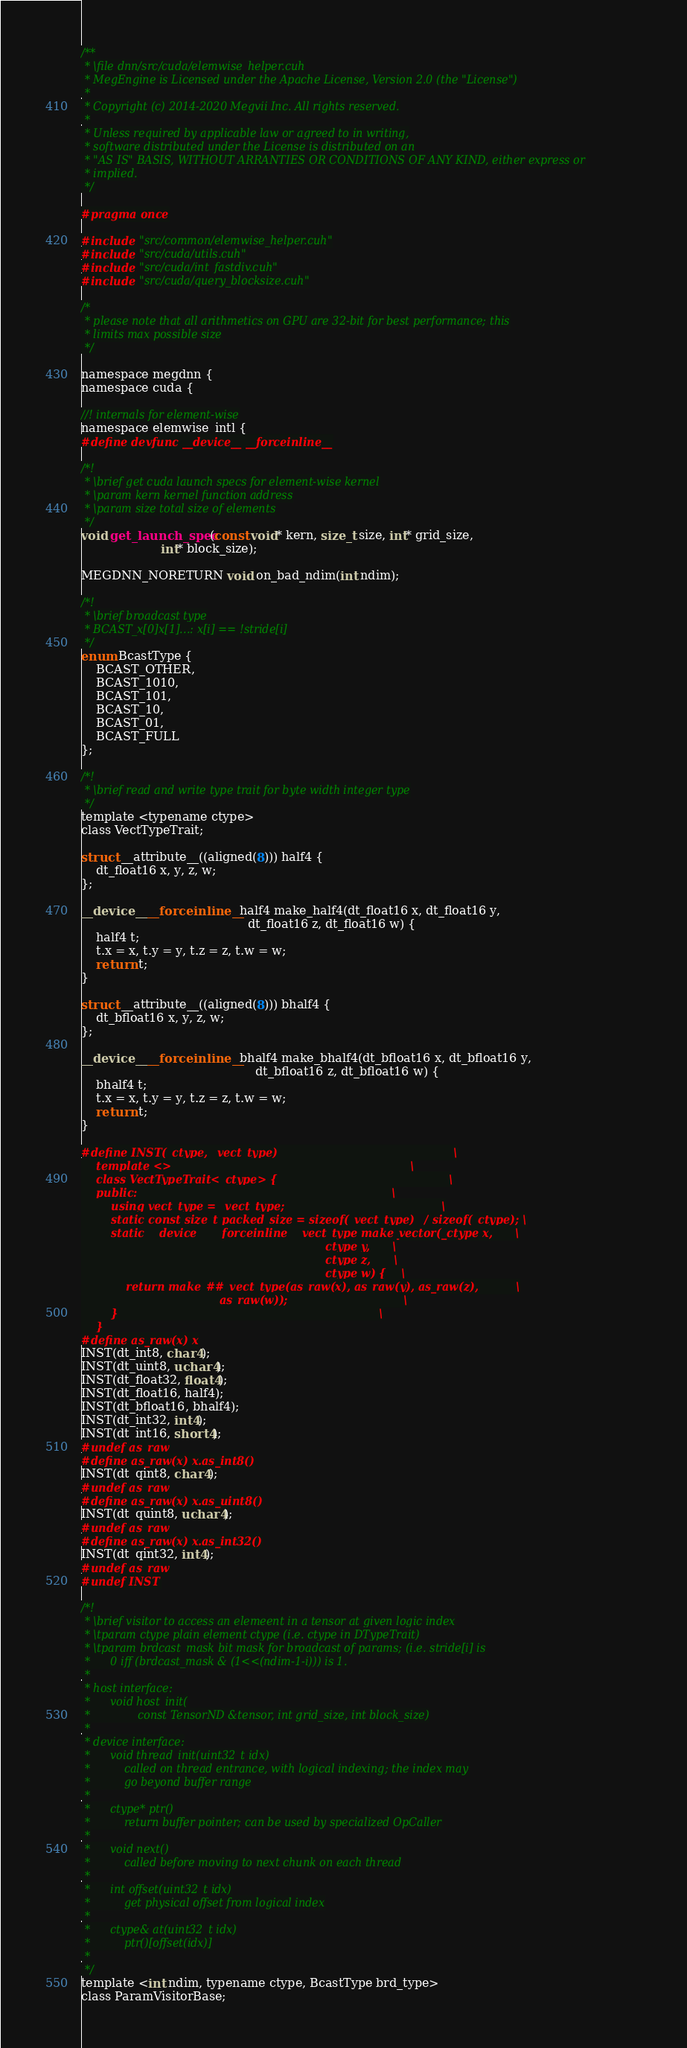<code> <loc_0><loc_0><loc_500><loc_500><_Cuda_>/**
 * \file dnn/src/cuda/elemwise_helper.cuh
 * MegEngine is Licensed under the Apache License, Version 2.0 (the "License")
 *
 * Copyright (c) 2014-2020 Megvii Inc. All rights reserved.
 *
 * Unless required by applicable law or agreed to in writing,
 * software distributed under the License is distributed on an
 * "AS IS" BASIS, WITHOUT ARRANTIES OR CONDITIONS OF ANY KIND, either express or
 * implied.
 */

#pragma once

#include "src/common/elemwise_helper.cuh"
#include "src/cuda/utils.cuh"
#include "src/cuda/int_fastdiv.cuh"
#include "src/cuda/query_blocksize.cuh"

/*
 * please note that all arithmetics on GPU are 32-bit for best performance; this
 * limits max possible size
 */

namespace megdnn {
namespace cuda {

//! internals for element-wise
namespace elemwise_intl {
#define devfunc __device__ __forceinline__

/*!
 * \brief get cuda launch specs for element-wise kernel
 * \param kern kernel function address
 * \param size total size of elements
 */
void get_launch_spec(const void* kern, size_t size, int* grid_size,
                     int* block_size);

MEGDNN_NORETURN void on_bad_ndim(int ndim);

/*!
 * \brief broadcast type
 * BCAST_x[0]x[1]...: x[i] == !stride[i]
 */
enum BcastType {
    BCAST_OTHER,
    BCAST_1010,
    BCAST_101,
    BCAST_10,
    BCAST_01,
    BCAST_FULL
};

/*!
 * \brief read and write type trait for byte width integer type
 */
template <typename ctype>
class VectTypeTrait;

struct __attribute__((aligned(8))) half4 {
    dt_float16 x, y, z, w;
};

__device__ __forceinline__ half4 make_half4(dt_float16 x, dt_float16 y,
                                            dt_float16 z, dt_float16 w) {
    half4 t;
    t.x = x, t.y = y, t.z = z, t.w = w;
    return t;
}

struct __attribute__((aligned(8))) bhalf4 {
    dt_bfloat16 x, y, z, w;
};

__device__ __forceinline__ bhalf4 make_bhalf4(dt_bfloat16 x, dt_bfloat16 y,
                                              dt_bfloat16 z, dt_bfloat16 w) {
    bhalf4 t;
    t.x = x, t.y = y, t.z = z, t.w = w;
    return t;
}

#define INST(_ctype, _vect_type)                                               \
    template <>                                                                \
    class VectTypeTrait<_ctype> {                                              \
    public:                                                                    \
        using vect_type = _vect_type;                                          \
        static const size_t packed_size = sizeof(_vect_type) / sizeof(_ctype); \
        static __device__ __forceinline__ vect_type make_vector(_ctype x,      \
                                                                _ctype y,      \
                                                                _ctype z,      \
                                                                _ctype w) {    \
            return make_##_vect_type(as_raw(x), as_raw(y), as_raw(z),          \
                                     as_raw(w));                               \
        }                                                                      \
    }
#define as_raw(x) x
INST(dt_int8, char4);
INST(dt_uint8, uchar4);
INST(dt_float32, float4);
INST(dt_float16, half4);
INST(dt_bfloat16, bhalf4);
INST(dt_int32, int4);
INST(dt_int16, short4);
#undef as_raw
#define as_raw(x) x.as_int8()
INST(dt_qint8, char4);
#undef as_raw
#define as_raw(x) x.as_uint8()
INST(dt_quint8, uchar4);
#undef as_raw
#define as_raw(x) x.as_int32()
INST(dt_qint32, int4);
#undef as_raw
#undef INST

/*!
 * \brief visitor to access an elemeent in a tensor at given logic index
 * \tparam ctype plain element ctype (i.e. ctype in DTypeTrait)
 * \tparam brdcast_mask bit mask for broadcast of params; (i.e. stride[i] is
 *      0 iff (brdcast_mask & (1<<(ndim-1-i))) is 1.
 *
 * host interface:
 *      void host_init(
 *              const TensorND &tensor, int grid_size, int block_size)
 *
 * device interface:
 *      void thread_init(uint32_t idx)
 *          called on thread entrance, with logical indexing; the index may
 *          go beyond buffer range
 *
 *      ctype* ptr()
 *          return buffer pointer; can be used by specialized OpCaller
 *
 *      void next()
 *          called before moving to next chunk on each thread
 *
 *      int offset(uint32_t idx)
 *          get physical offset from logical index
 *
 *      ctype& at(uint32_t idx)
 *          ptr()[offset(idx)]
 *
 */
template <int ndim, typename ctype, BcastType brd_type>
class ParamVisitorBase;
</code> 